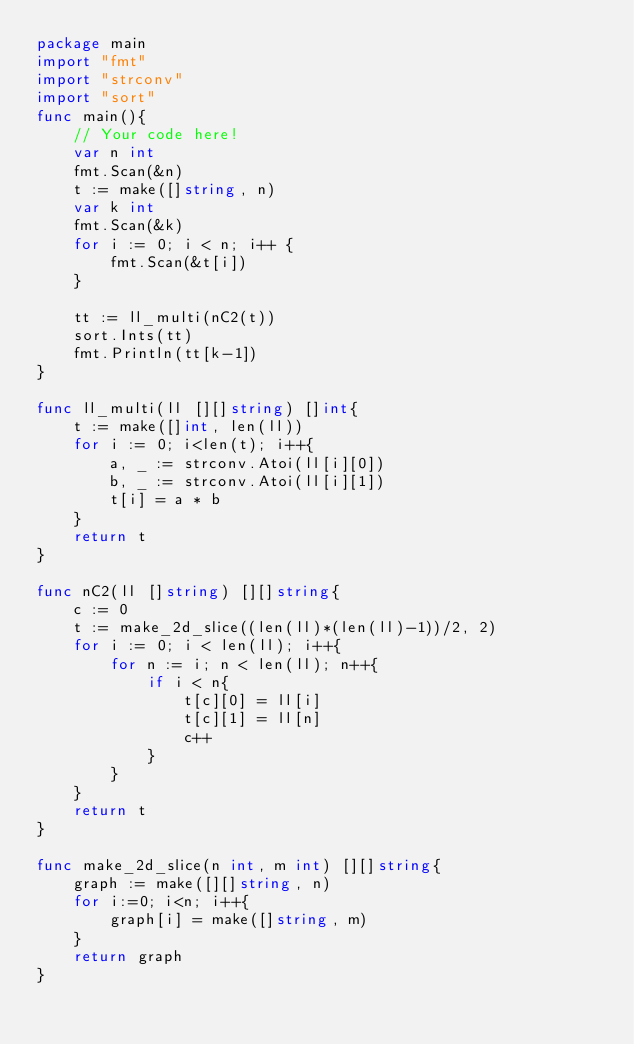<code> <loc_0><loc_0><loc_500><loc_500><_Go_>package main
import "fmt"
import "strconv"
import "sort"
func main(){
    // Your code here!
    var n int
    fmt.Scan(&n)
    t := make([]string, n)
    var k int
    fmt.Scan(&k)
    for i := 0; i < n; i++ {
        fmt.Scan(&t[i])
    }
    
    tt := ll_multi(nC2(t))
    sort.Ints(tt)
    fmt.Println(tt[k-1])
}

func ll_multi(ll [][]string) []int{
    t := make([]int, len(ll))
    for i := 0; i<len(t); i++{
        a, _ := strconv.Atoi(ll[i][0])
        b, _ := strconv.Atoi(ll[i][1])
        t[i] = a * b 
    }
    return t
}

func nC2(ll []string) [][]string{
    c := 0
    t := make_2d_slice((len(ll)*(len(ll)-1))/2, 2)
    for i := 0; i < len(ll); i++{
        for n := i; n < len(ll); n++{
            if i < n{
                t[c][0] = ll[i]
                t[c][1] = ll[n]
                c++
            }
        }
    }
    return t
}

func make_2d_slice(n int, m int) [][]string{
    graph := make([][]string, n)
    for i:=0; i<n; i++{
        graph[i] = make([]string, m)
    }
    return graph
}</code> 